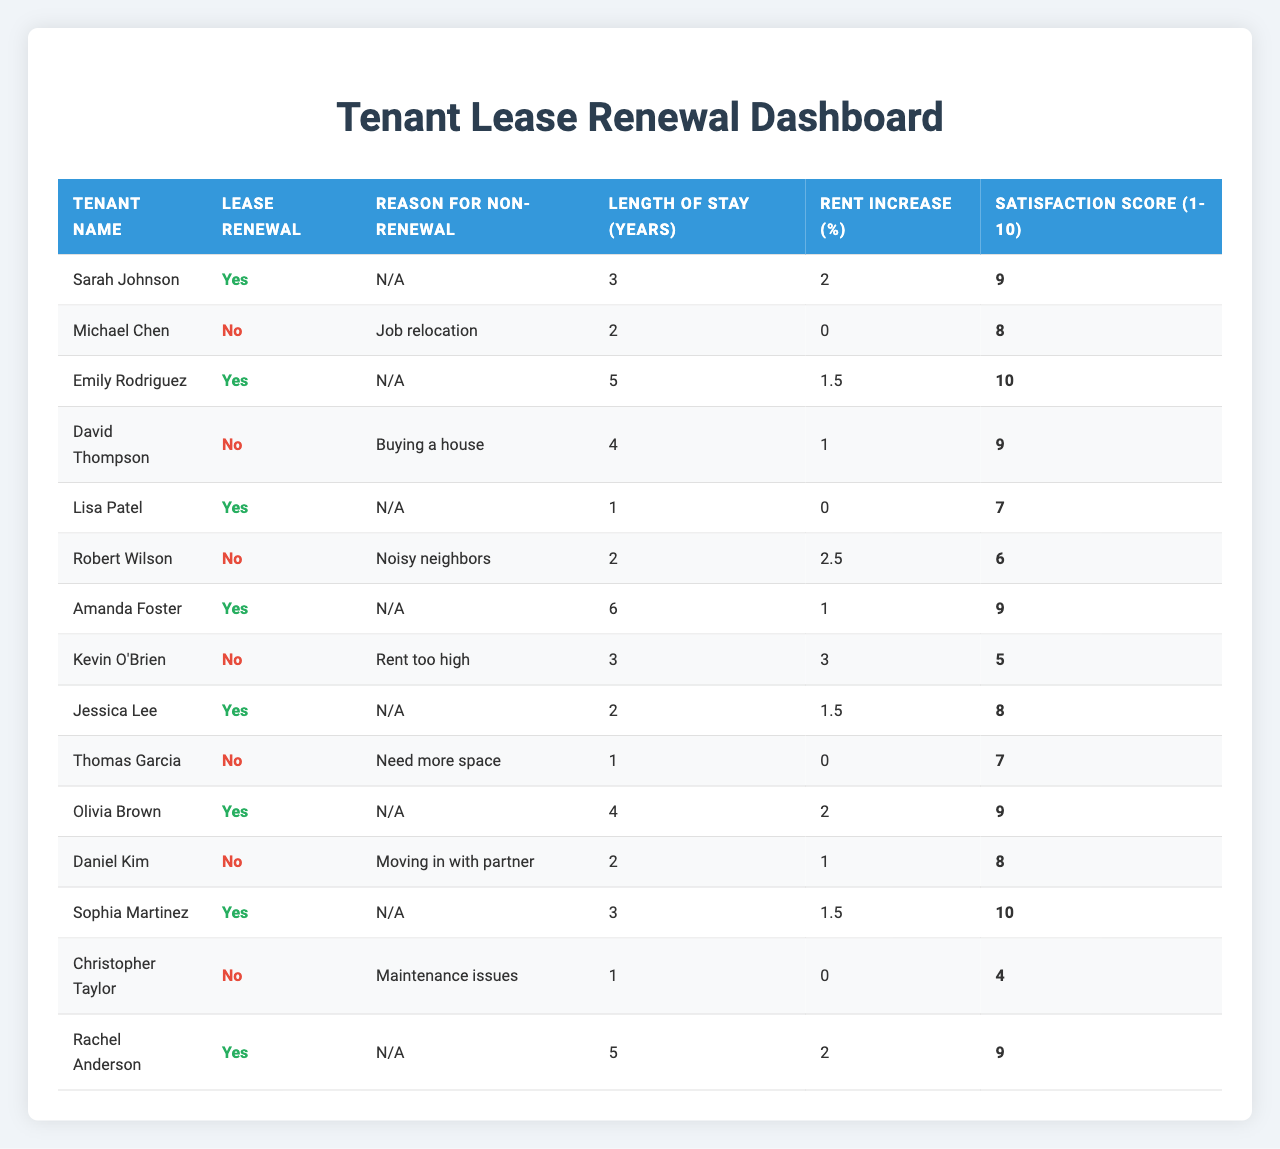What is the total number of tenants who chose to renew their lease? By counting the rows in the table where "Lease Renewal" is marked as "Yes," we find six tenants renewing their lease: Sarah Johnson, Emily Rodriguez, Lisa Patel, Amanda Foster, Olivia Brown, and Rachel Anderson.
Answer: 6 What percentage of tenants decided not to renew their lease? There are 14 tenants in total, and 6 of them did not renew their lease. The percentage is calculated as (6/14) * 100 = 42.86%.
Answer: 42.86% What is the average satisfaction score of tenants who renewed their lease? The satisfaction scores for the renewing tenants are 9, 10, 7, 9, 9, and 10. The average is calculated as (9 + 10 + 7 + 9 + 9 + 10) / 6 = 9.
Answer: 9 Which tenant stayed the longest before deciding not to renew their lease? Among those who did not renew, David Thompson stayed for 4 years, which is the longest compared to Michael Chen (2 years), Robert Wilson (2 years), Kevin O'Brien (3 years), Thomas Garcia (1 year), and Daniel Kim (2 years).
Answer: David Thompson Is there a correlation between satisfaction scores and lease renewals? Comparing the satisfaction scores: Renewing tenants have scores of 9, 10, 7, 9, 9, and 10, while non-renewing tenants have scores of 8, 9, 6, 5, 7, and 8. The average satisfaction score for renewing tenants is higher than for non-renewing, indicating a positive correlation.
Answer: Yes, higher satisfaction correlates with renewals What is the most common reason for tenants not renewing their lease? The reasons for non-renewal include job relocation, buying a house, noisy neighbors, rent too high, need for more space, moving in with a partner, and maintenance issues. Noisy neighbors and rent too high each appear once, while all others are unique.
Answer: Unique reasons, no most common Which tenant experienced the highest rent increase and did not renew their lease? Kevin O'Brien had a 3% rent increase and chose not to renew his lease, which is the highest percentage among those who did not renew.
Answer: Kevin O'Brien Could we conclude that tenants who had a rent increase are less satisfied? Observing the table, Robert Wilson and Kevin O'Brien had rent increases of 2.5% and 3%, respectively, and both did not renew their lease. In contrast, renewing tenants with increases had varied satisfaction. Though some evidence points towards dissatisfaction with increases, not all tenants who renewed had increases.
Answer: Partially true, but not conclusive 